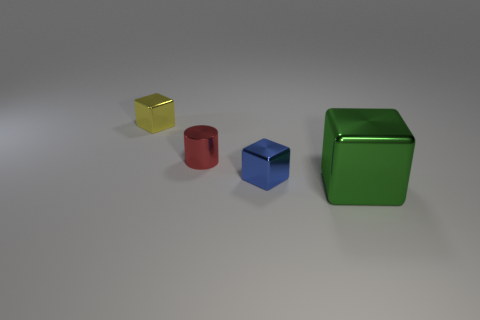Add 4 big yellow matte blocks. How many objects exist? 8 Subtract all cylinders. How many objects are left? 3 Add 4 big green cubes. How many big green cubes exist? 5 Subtract 0 blue spheres. How many objects are left? 4 Subtract all small red cylinders. Subtract all large metallic blocks. How many objects are left? 2 Add 3 yellow blocks. How many yellow blocks are left? 4 